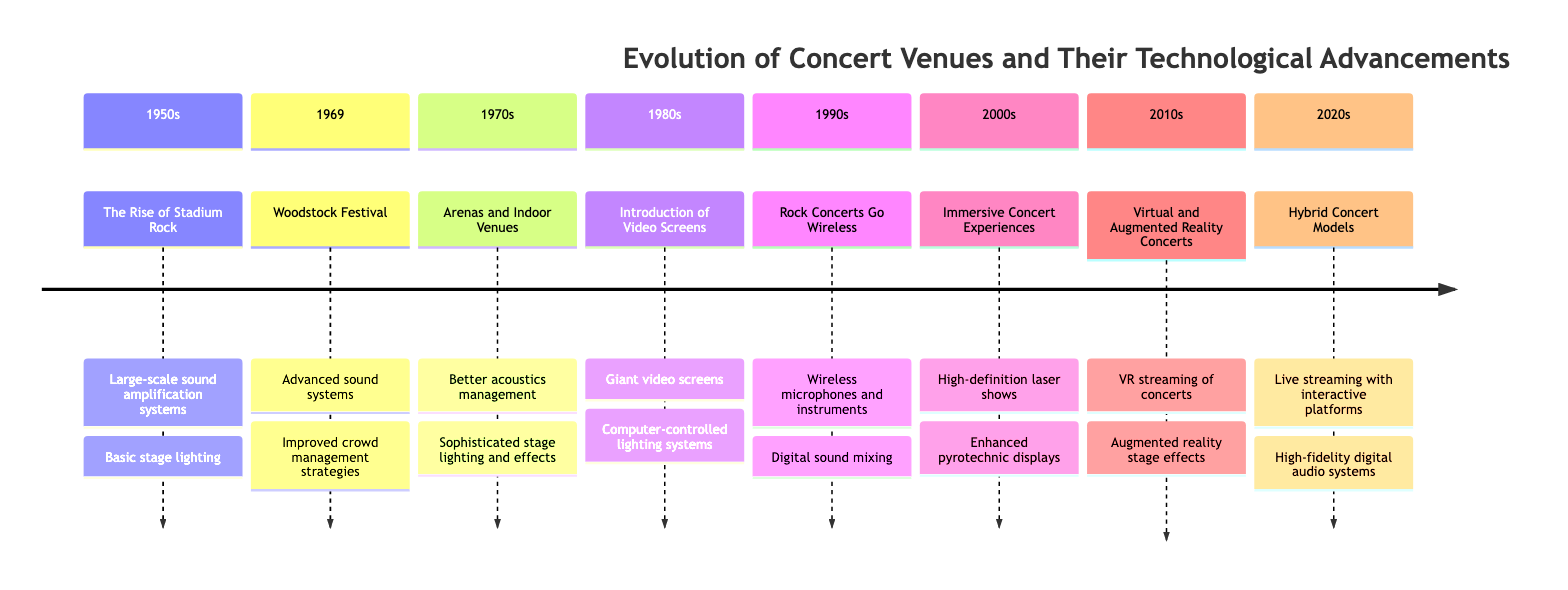What decade saw the introduction of giant video screens? The diagram lists the decade of the 1980s as when the introduction of giant video screens occurred.
Answer: 1980s What technological advancement was introduced in the 2000s? The section for the 2000s indicates "High-definition laser shows" as one of the technological advancements during that decade.
Answer: High-definition laser shows How many events are listed for the 1970s? The timeline for the 1970s includes one event, specifically "Arenas and Indoor Venues."
Answer: 1 Which event is associated with improved crowd management strategies? The diagram associates improved crowd management strategies with the "Woodstock Festival" that occurred in 1969.
Answer: Woodstock Festival What was a technological advancement in the 2010s? The timeline shows "VR streaming of concerts" as a technological advancement for the 2010s.
Answer: VR streaming of concerts Which decade marks the onset of hybrid concert models? According to the timeline, the 2020s marks the onset of hybrid concert models.
Answer: 2020s List two advancements from the 1990s. The diagram indicates "Wireless microphones and instruments" and "Digital sound mixing" are both advancements from the 1990s.
Answer: Wireless microphones and instruments, Digital sound mixing What was the main focus of concert venues in the 1950s? In the 1950s, the main focus of concert venues was on the "The Rise of Stadium Rock," which aimed at large open-air concerts.
Answer: The Rise of Stadium Rock What consistency is observed in technological advancements from the 1970s and 1980s? Both the 1970s and 1980s highlight the evolution towards better sound and visual experiences, showcasing advancements in stage elements like "Sophisticated stage lighting and effects" and "Computer-controlled lighting systems."
Answer: Better sound and visual experiences 